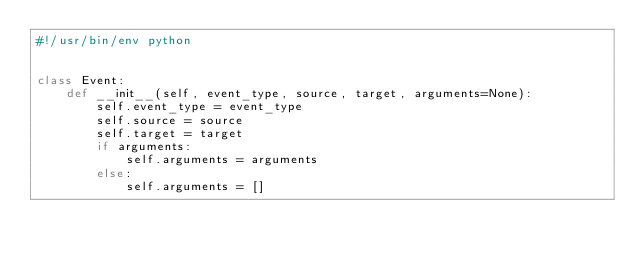Convert code to text. <code><loc_0><loc_0><loc_500><loc_500><_Python_>#!/usr/bin/env python


class Event:
    def __init__(self, event_type, source, target, arguments=None):
        self.event_type = event_type
        self.source = source
        self.target = target
        if arguments:
            self.arguments = arguments
        else:
            self.arguments = []
</code> 